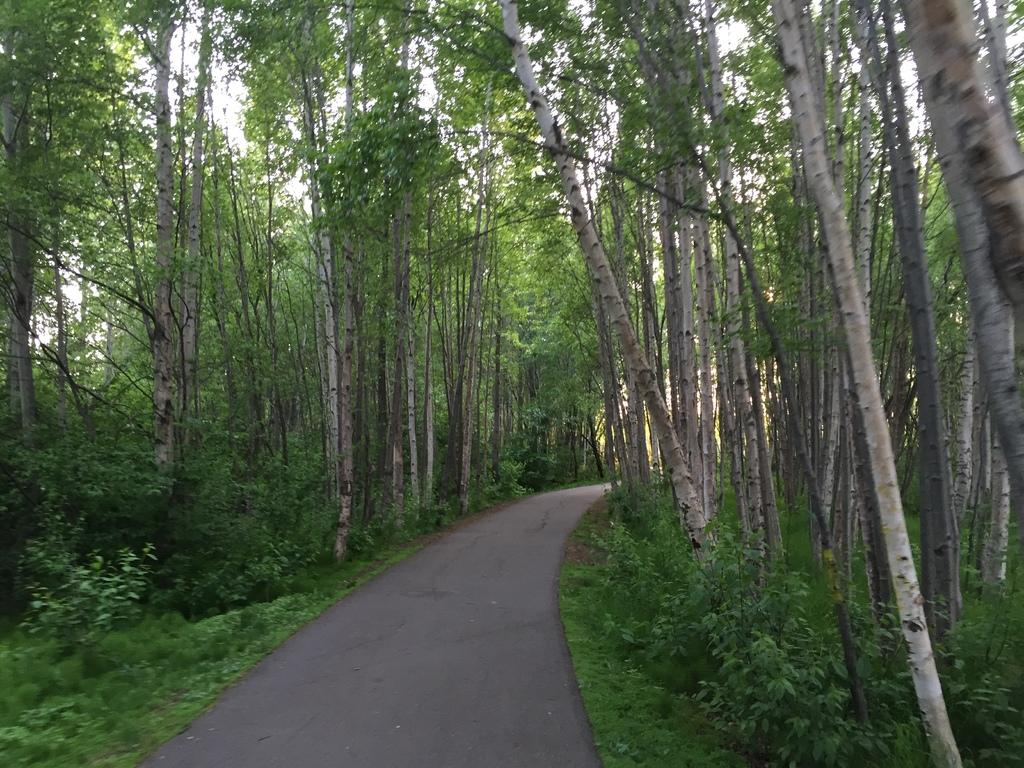What is the main feature in the center of the image? There is a road in the center of the image. What type of vegetation can be seen on both sides of the road? There are trees on both sides of the image. What type of ground is visible at the bottom of the image? There is grass at the bottom of the image. What type of underwear is hanging on the trees in the image? There is no underwear present in the image; it only features a road, trees, and grass. 